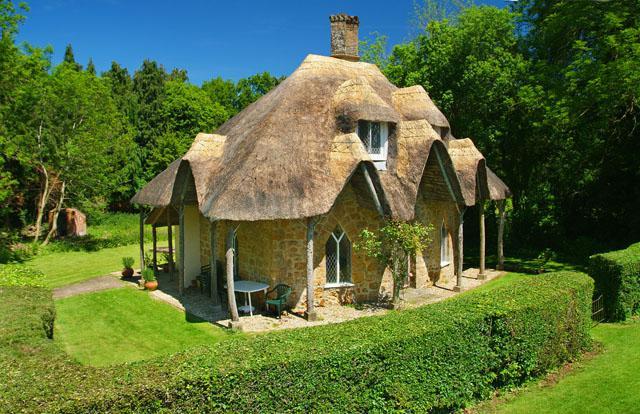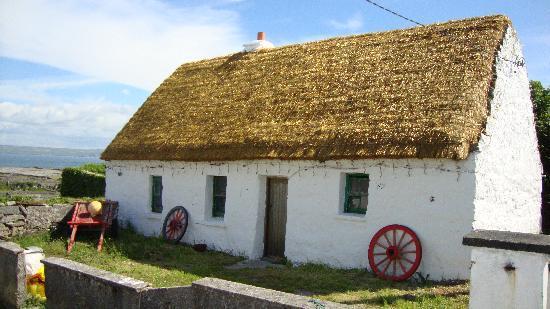The first image is the image on the left, the second image is the image on the right. Given the left and right images, does the statement "The left image shows a white house with bold dark lines on it forming geometric patterns, and a thatched roof with at least one notched cut-out for windows, and the right image shows a house with a thatched roof over the door and a roof over the house itself." hold true? Answer yes or no. No. 